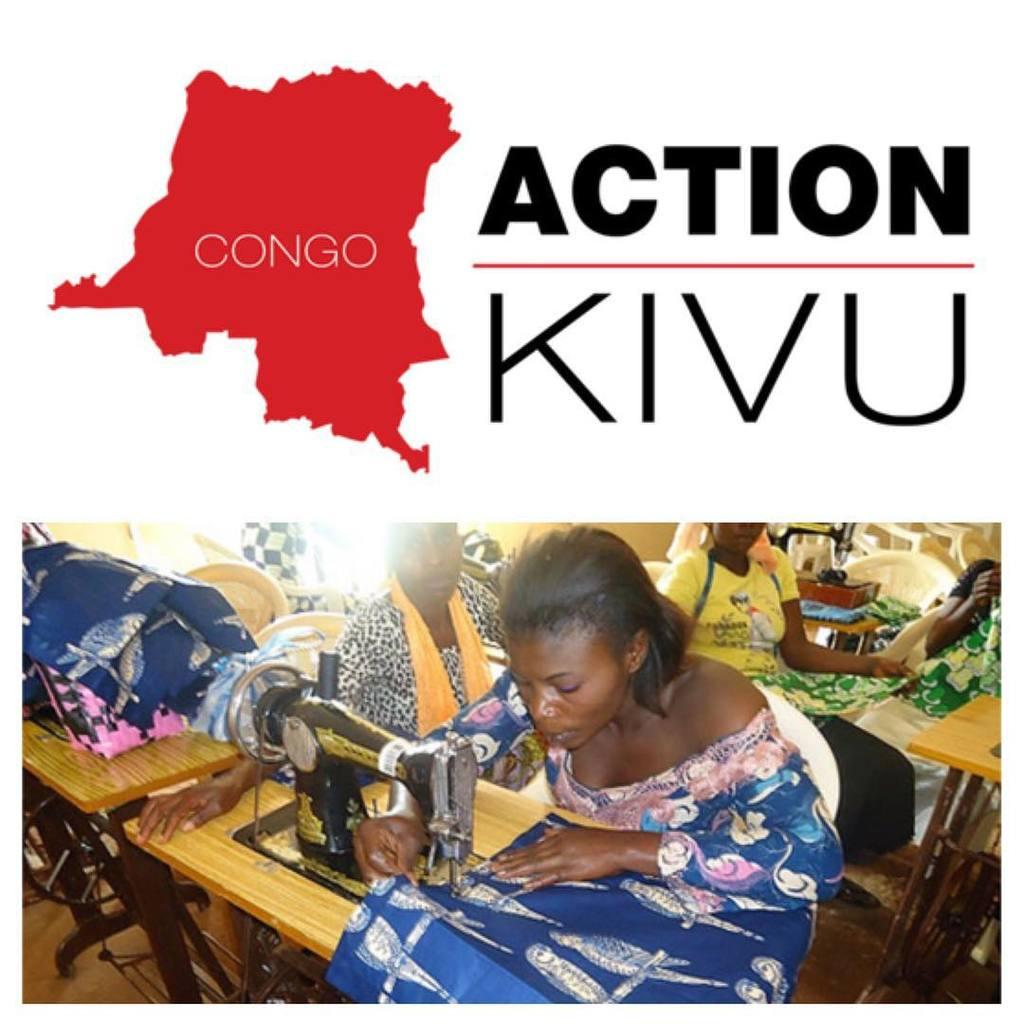What are the women in the image doing? The women are sitting on chairs in the image. What objects are on the wooden tables in the image? There are machines on wooden tables in the image. Can you describe the background of the image? There are chairs visible in the background of the image. What brand or company might be associated with the image? There is a logo present in the image, which could indicate a brand or company. What type of mint is growing in the image? There is no mint present in the image. Where is the sink located in the image? There is no sink present in the image. 